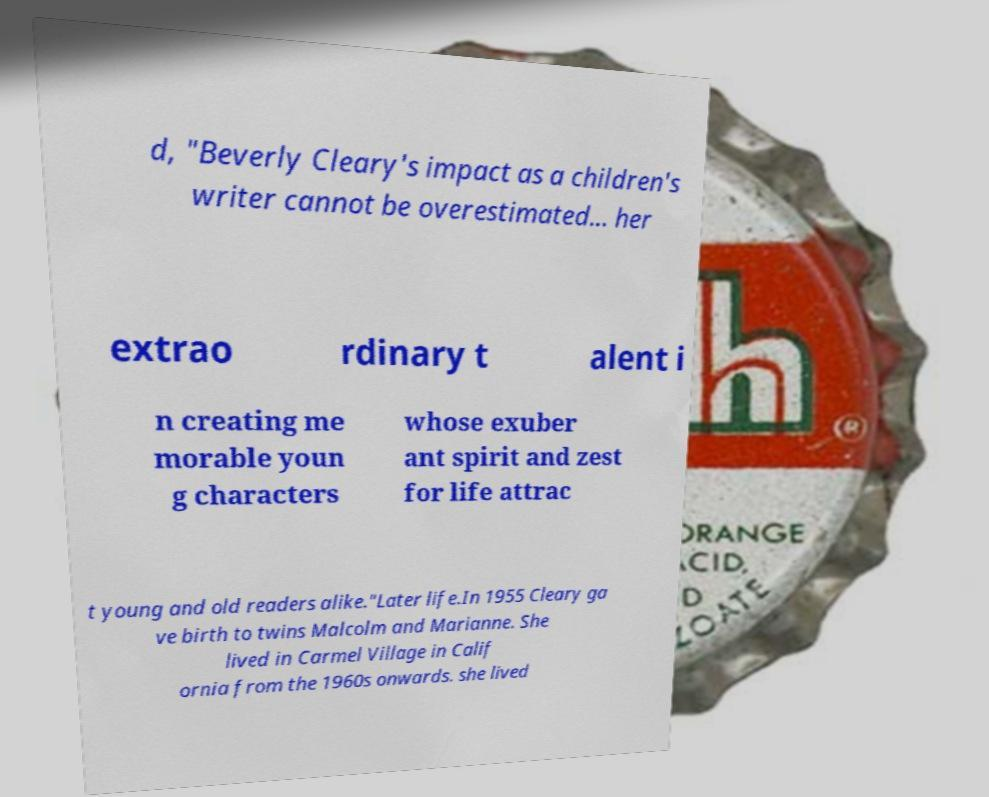Can you accurately transcribe the text from the provided image for me? d, "Beverly Cleary's impact as a children's writer cannot be overestimated... her extrao rdinary t alent i n creating me morable youn g characters whose exuber ant spirit and zest for life attrac t young and old readers alike."Later life.In 1955 Cleary ga ve birth to twins Malcolm and Marianne. She lived in Carmel Village in Calif ornia from the 1960s onwards. she lived 